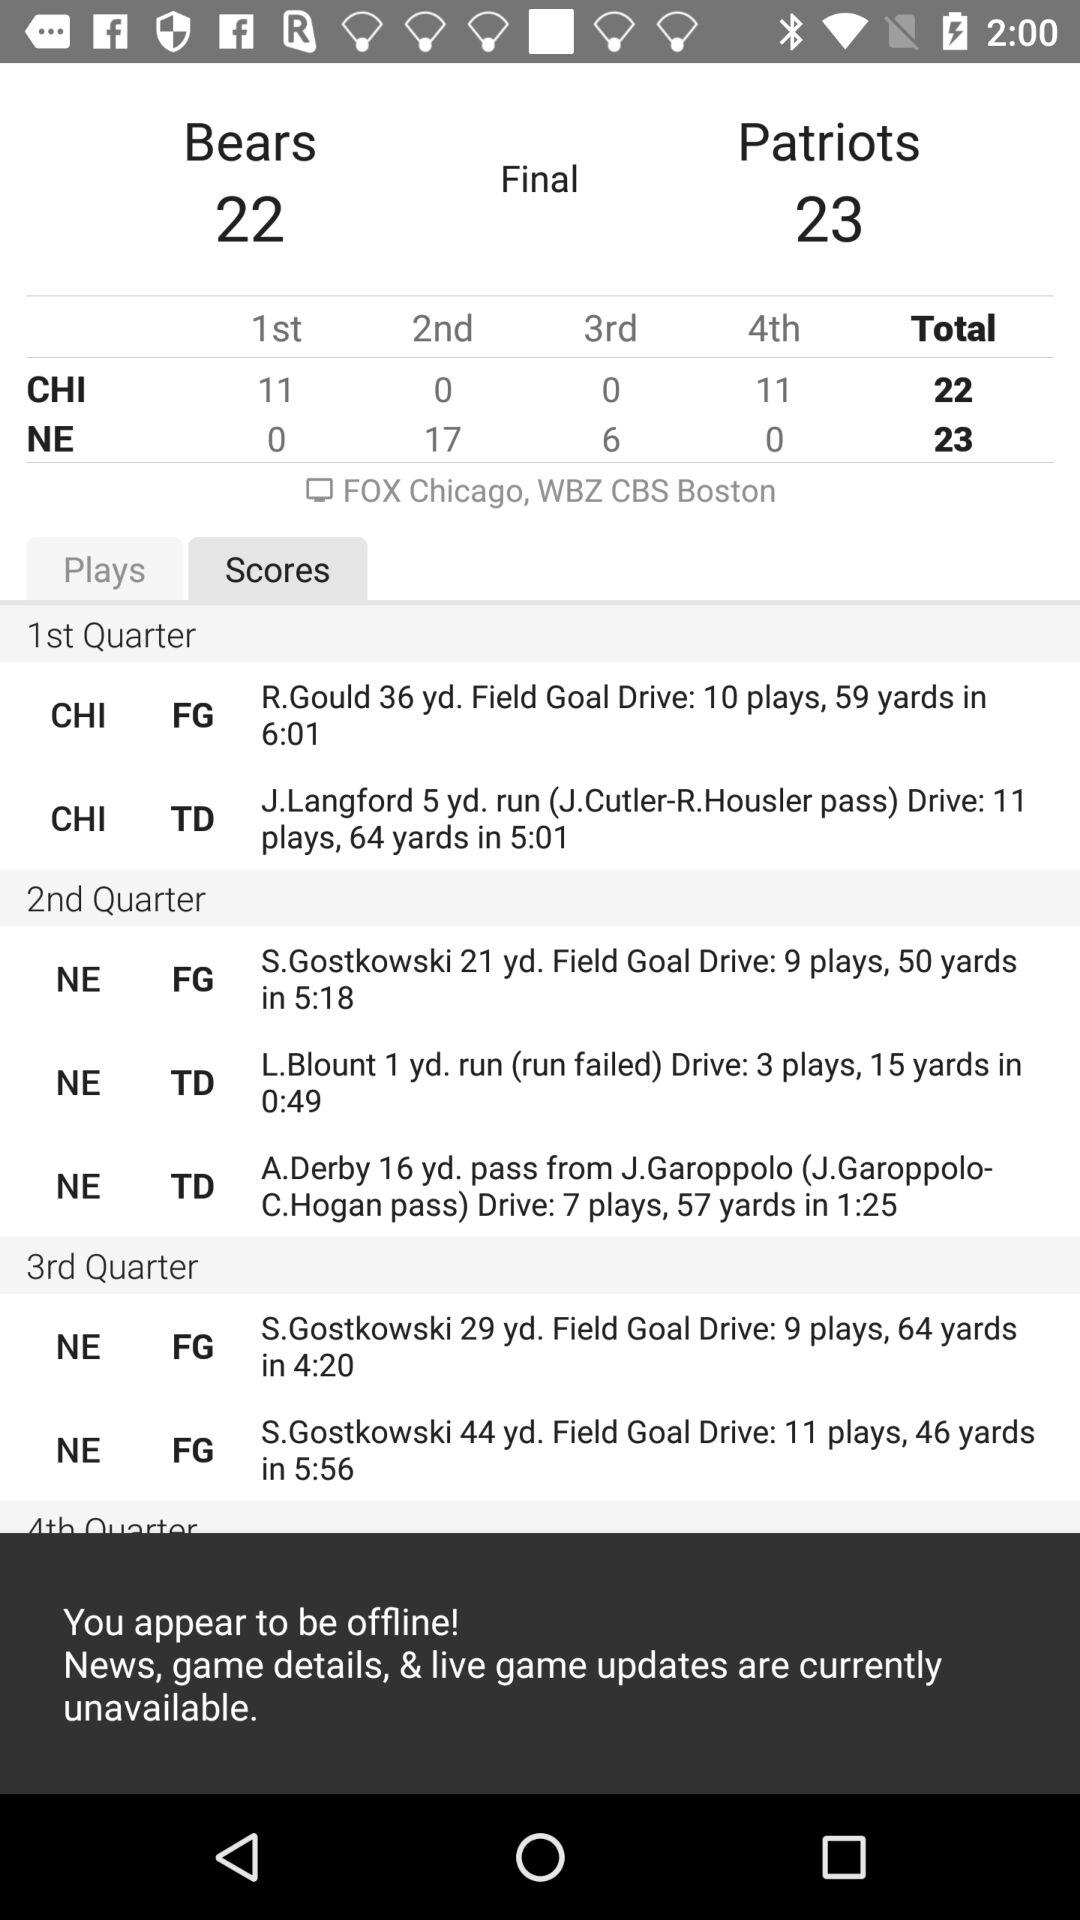1st quarter is between whom?
When the provided information is insufficient, respond with <no answer>. <no answer> 